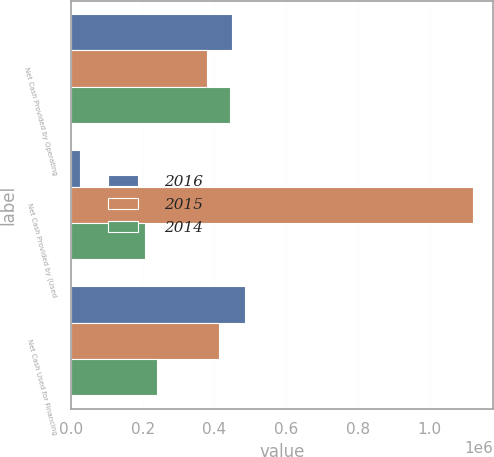<chart> <loc_0><loc_0><loc_500><loc_500><stacked_bar_chart><ecel><fcel>Net Cash Provided by Operating<fcel>Net Cash Provided by (Used<fcel>Net Cash Used for Financing<nl><fcel>2016<fcel>450135<fcel>24904<fcel>484933<nl><fcel>2015<fcel>379381<fcel>1.1213e+06<fcel>411934<nl><fcel>2014<fcel>444487<fcel>207031<fcel>238809<nl></chart> 